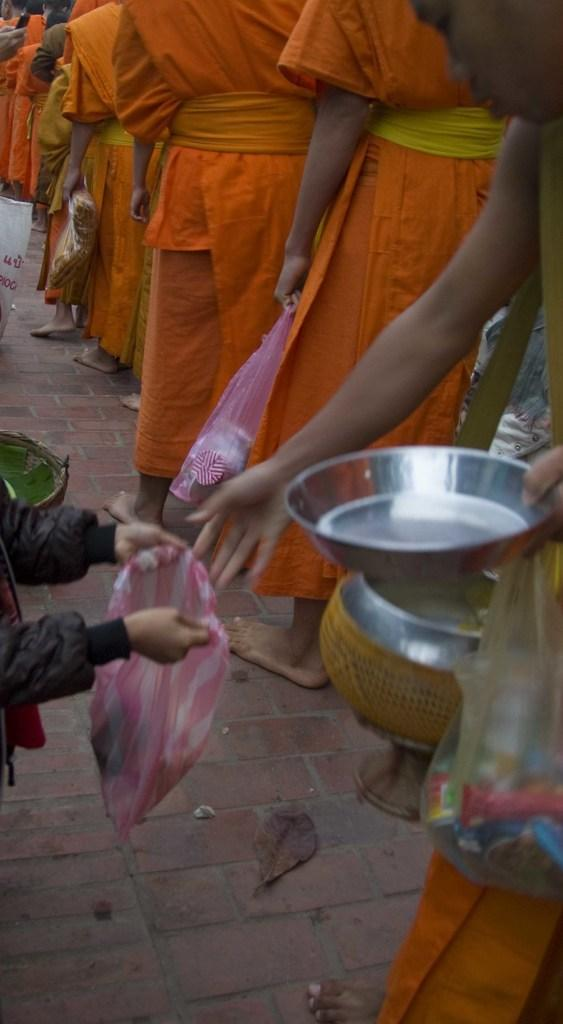What are the people in the image doing? The people in the image are standing on the floor and holding covers, baskets, and plates. What is inside the covers that the people are holding? There are objects in the covers that the people are holding. What might the people be preparing to do with the baskets and plates? The people might be preparing to serve or distribute food or items from the baskets and plates. What type of flower is being used as a wrench in the image? There is no flower or wrench present in the image. 